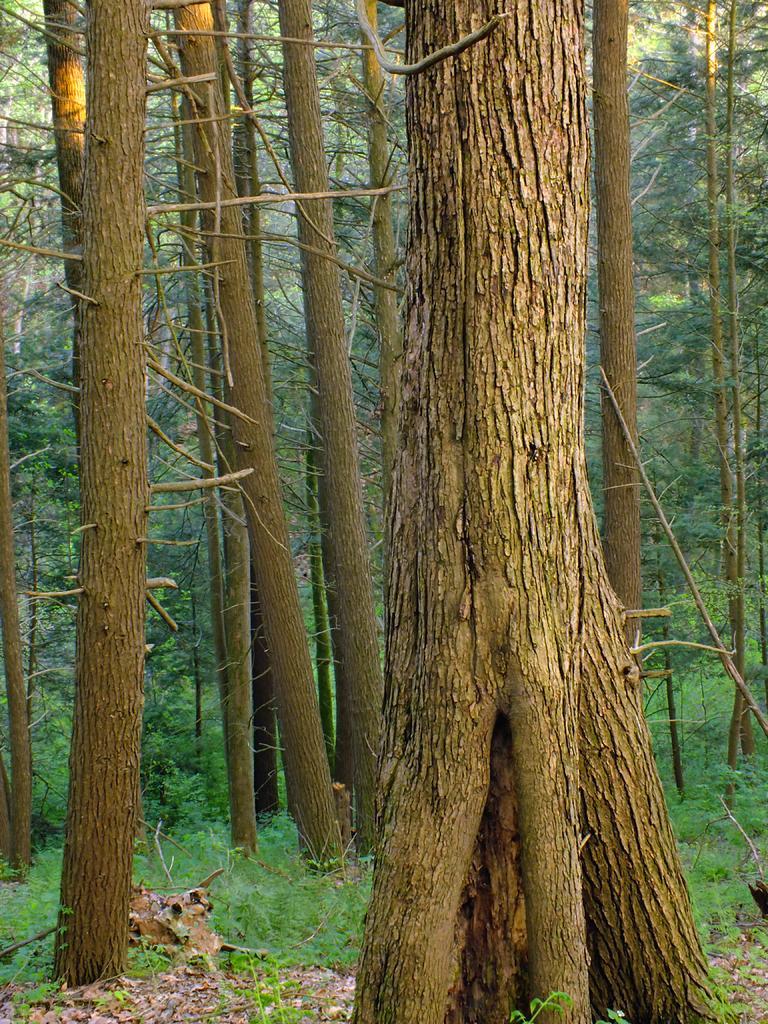Could you give a brief overview of what you see in this image? In this picture we can see there are tree trunks, plants and trees. 